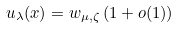<formula> <loc_0><loc_0><loc_500><loc_500>u _ { \lambda } ( x ) = w _ { \mu , \zeta } \, ( 1 + o ( 1 ) )</formula> 